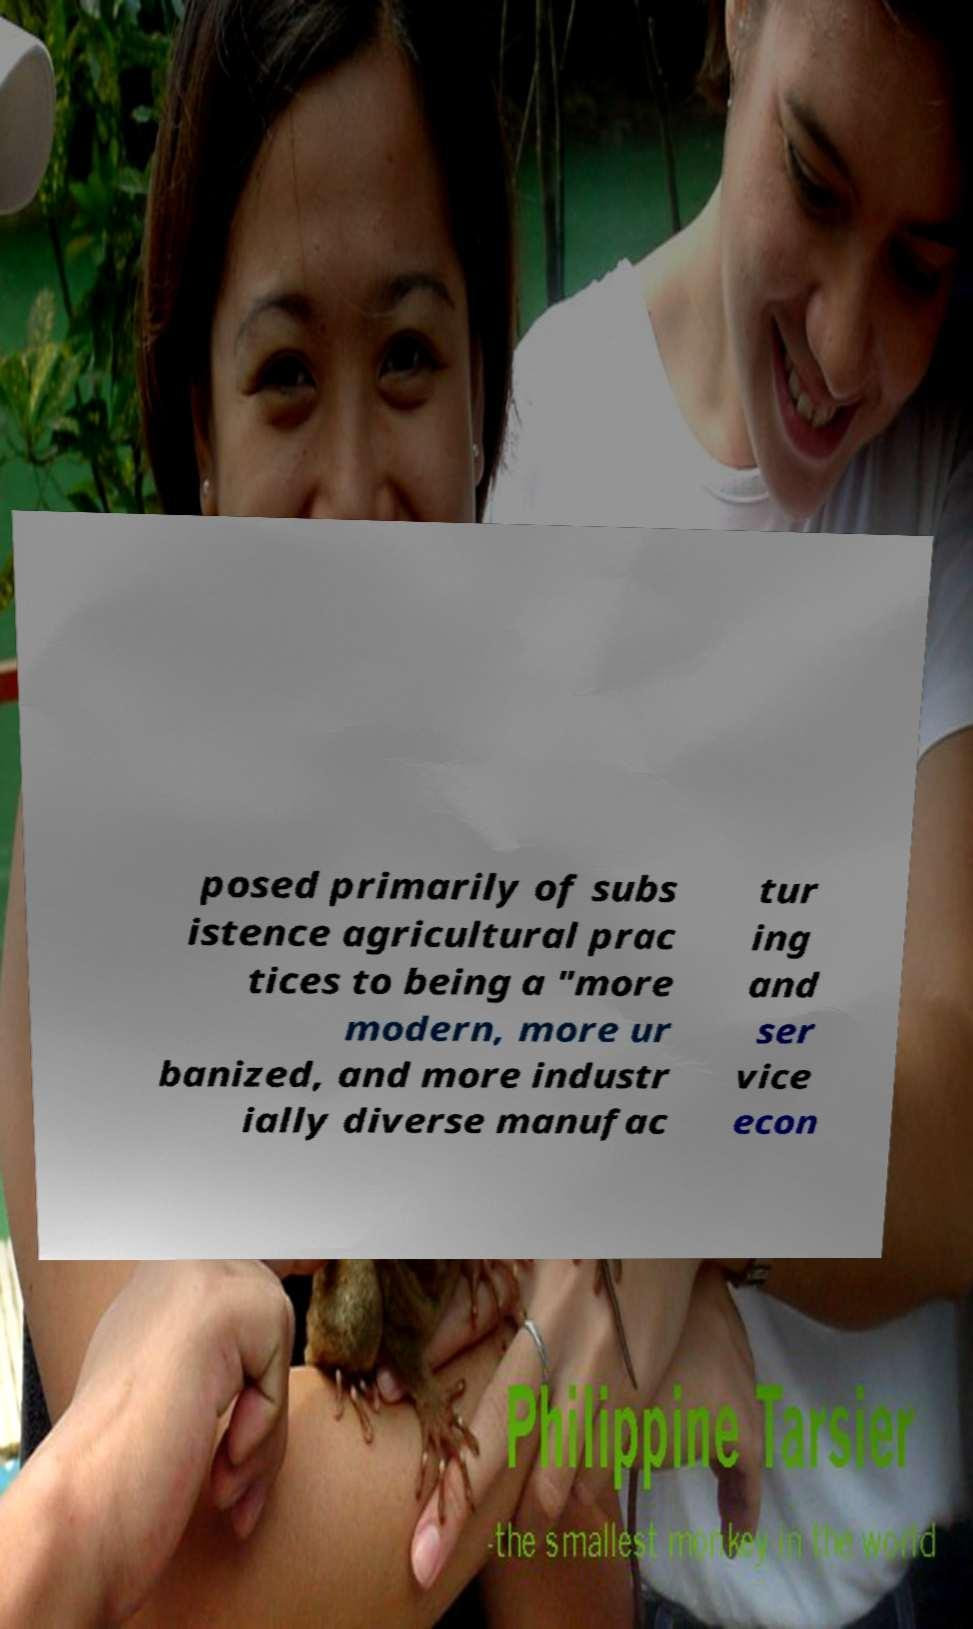Please read and relay the text visible in this image. What does it say? posed primarily of subs istence agricultural prac tices to being a "more modern, more ur banized, and more industr ially diverse manufac tur ing and ser vice econ 